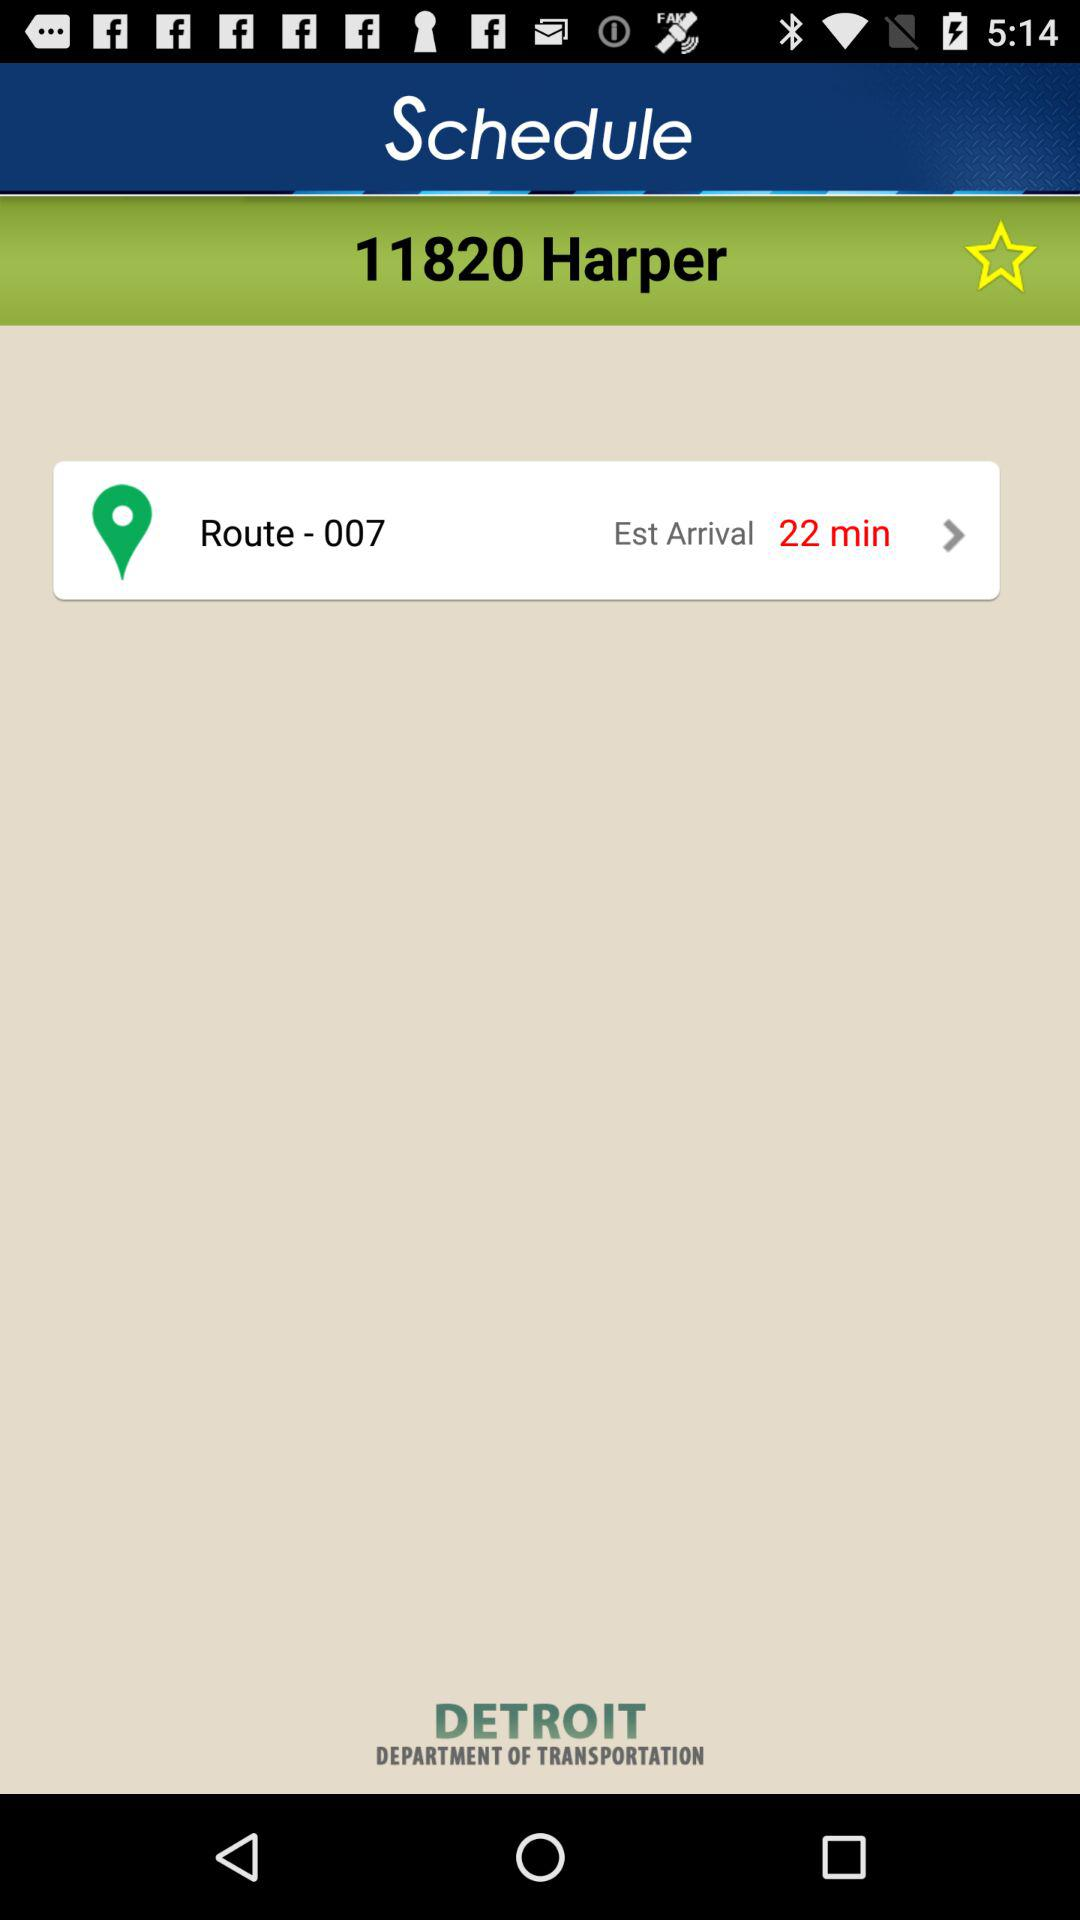What is the number of the route? The number of the route is 007. 